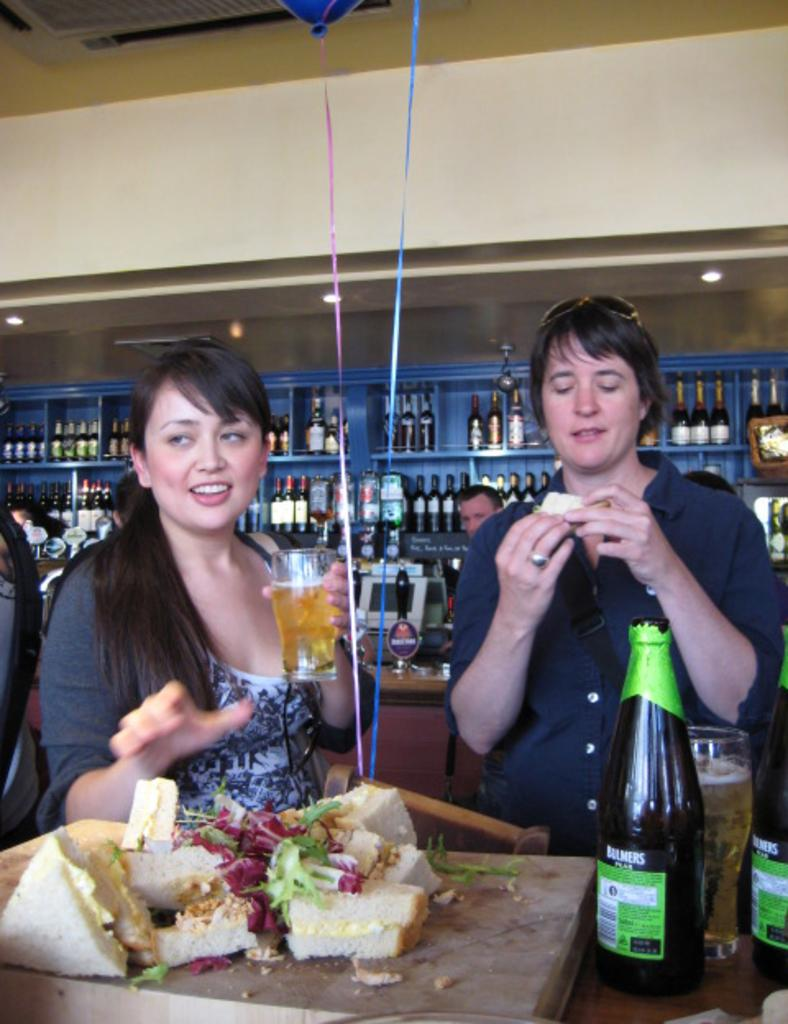<image>
Give a short and clear explanation of the subsequent image. Two customers in an establishment that serves drinks and sandwiches. One style of drink is called Bulmers. 